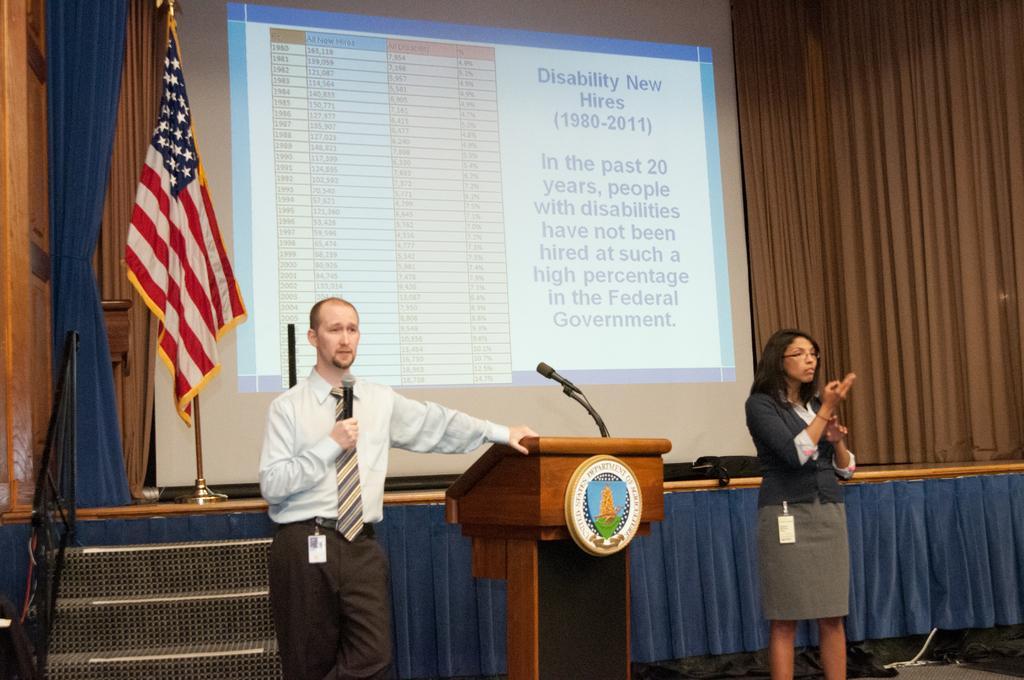Could you give a brief overview of what you see in this image? In the image in the center we can see two persons were standing and they were holding microphone. Between them,we can see one wooden stand and microphone. In the background there is a wooden wall,curtain,screen,flag,staircase,fence and few other objects. 